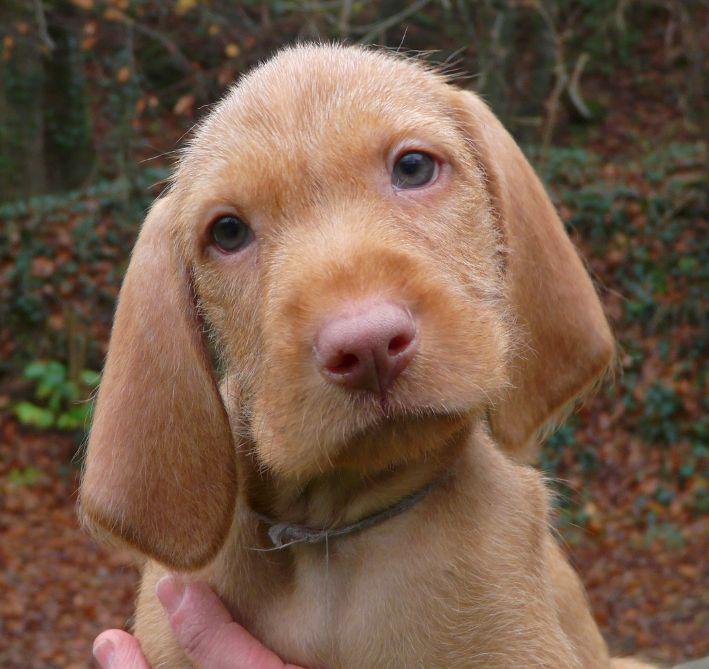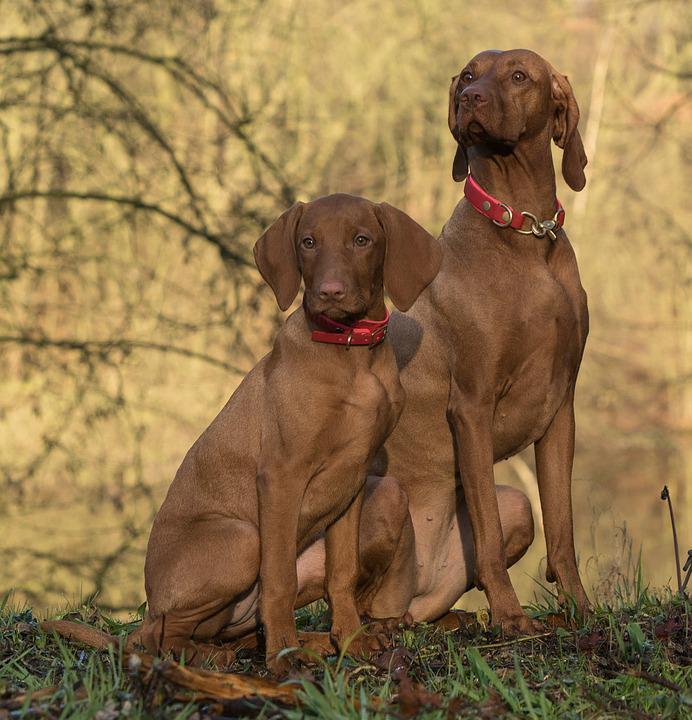The first image is the image on the left, the second image is the image on the right. For the images shown, is this caption "A dog walks through the grass as it carries something in its mouth." true? Answer yes or no. No. The first image is the image on the left, the second image is the image on the right. Assess this claim about the two images: "The left image shows two look-alike dogs side-by-side, gazing in the same direction, and the right image shows one brown dog walking with an animal figure in its mouth.". Correct or not? Answer yes or no. No. 